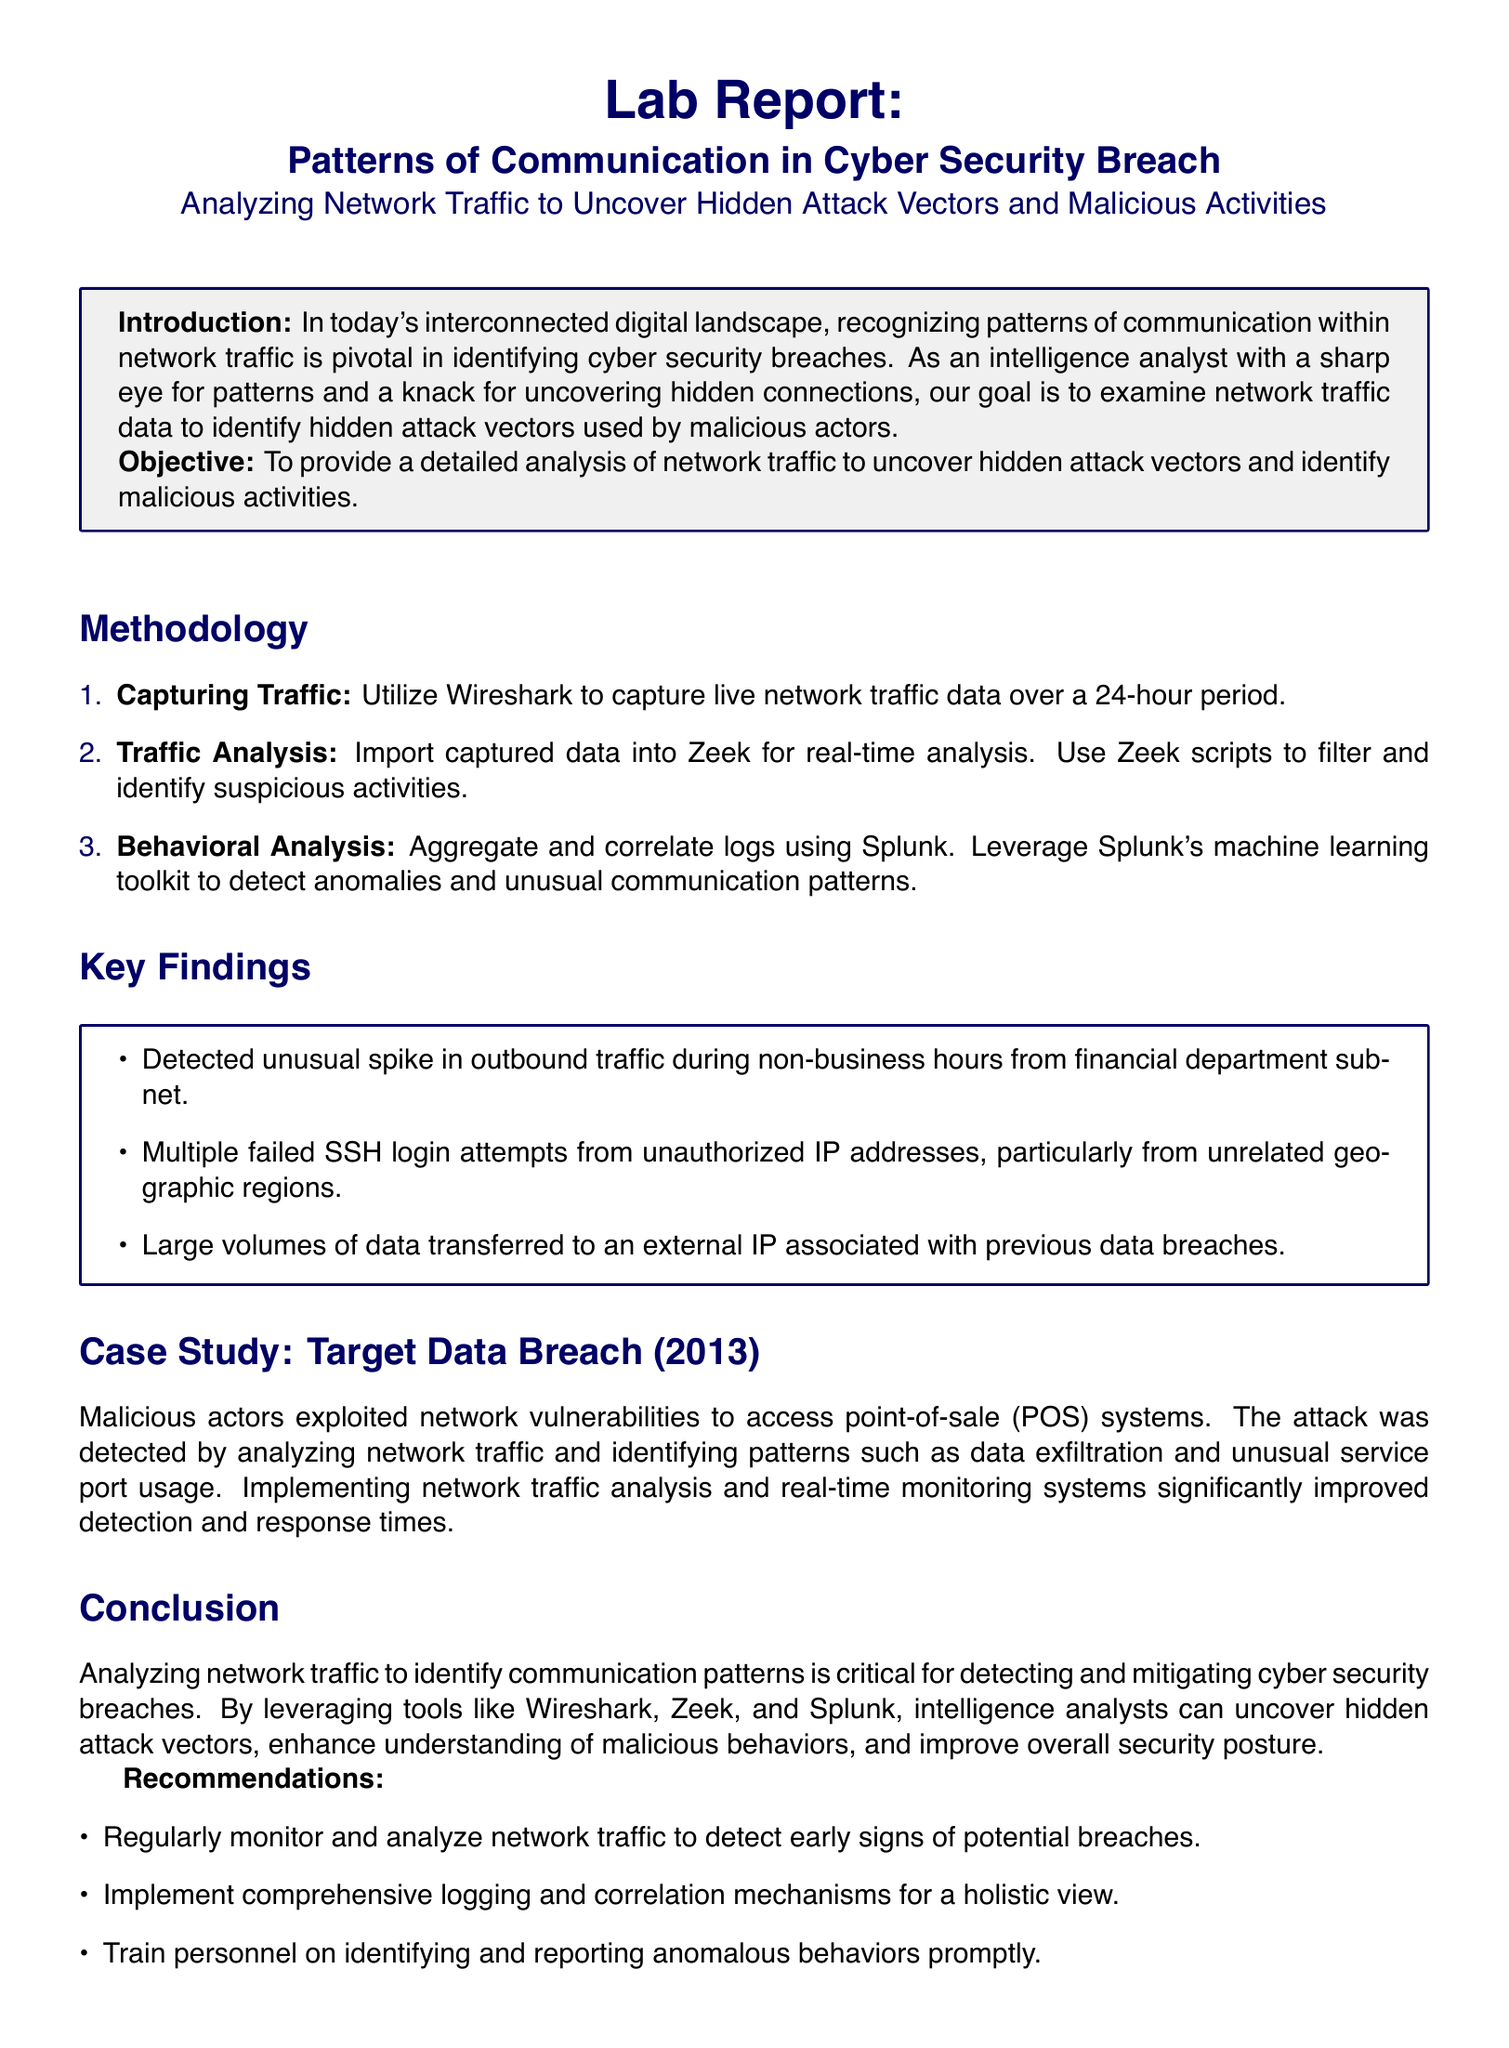What is the main objective of the lab report? The objective is to provide a detailed analysis of network traffic to uncover hidden attack vectors and identify malicious activities.
Answer: To provide a detailed analysis of network traffic to uncover hidden attack vectors and identify malicious activities How long was the network traffic captured? The document states that the network traffic was captured over a 24-hour period.
Answer: 24-hour period Which tool was used to capture the network traffic? The document specifies that Wireshark was used to capture live network traffic data.
Answer: Wireshark What significant finding was detected in the financial department subnet? The document mentions that an unusual spike in outbound traffic was detected during non-business hours.
Answer: Unusual spike in outbound traffic during non-business hours Which geographic regions showed unauthorized SSH login attempts? The document indicates that the unauthorized IP addresses were from unrelated geographic regions.
Answer: Unrelated geographic regions What attack was studied in the case study section? The case study focuses on the Target Data Breach that occurred in 2013.
Answer: Target Data Breach (2013) What is recommended for personnel in relation to anomalous behaviors? The recommendation is to train personnel on identifying and reporting anomalous behaviors promptly.
Answer: Train personnel on identifying and reporting anomalous behaviors promptly What was a key method for identifying malicious activities mentioned in the report? The report highlights the use of behavioral analysis and correlation of logs using Splunk as a key method.
Answer: Behavioral analysis and correlation of logs using Splunk How can tools like Zeek and Splunk aid analysts? The tools aid analysts by uncovering hidden attack vectors and enhancing understanding of malicious behaviors.
Answer: Uncovering hidden attack vectors and enhancing understanding of malicious behaviors 